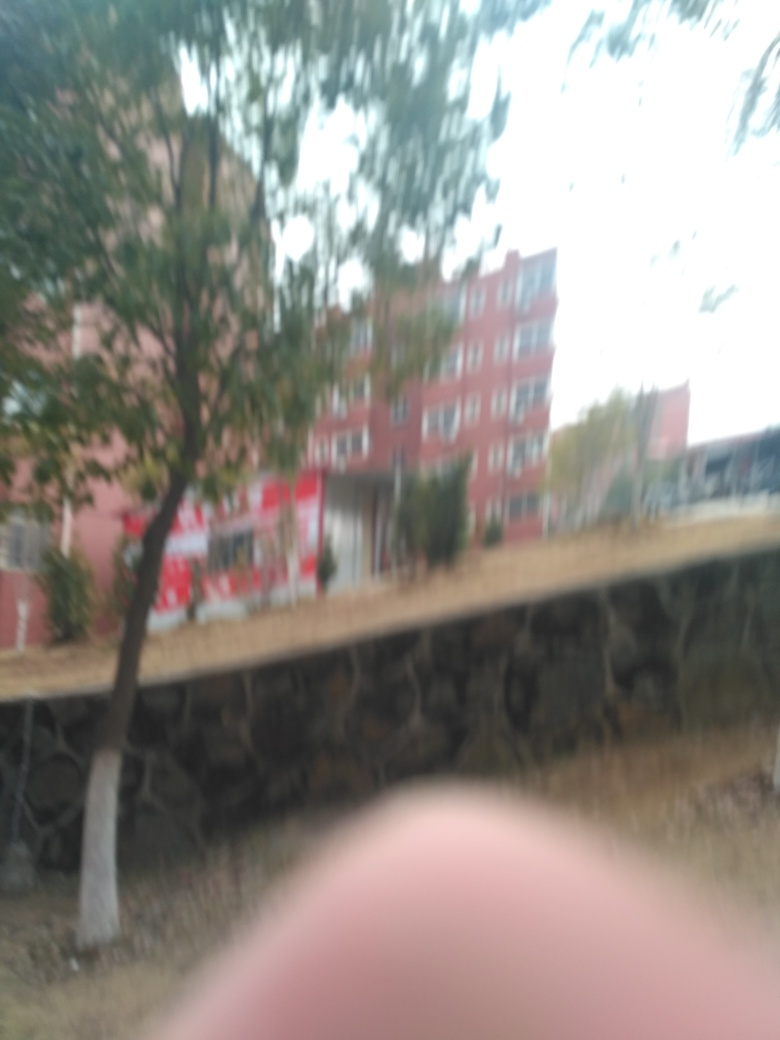What tips would you give to improve the quality of a photo like this? To improve the quality of similar photos, one should ensure stable camera holding techniques or use a tripod, select the appropriate camera settings like faster shutter speed to prevent motion blur, and use the autofocus feature effectively or manually focus to ensure clarity in the image. 